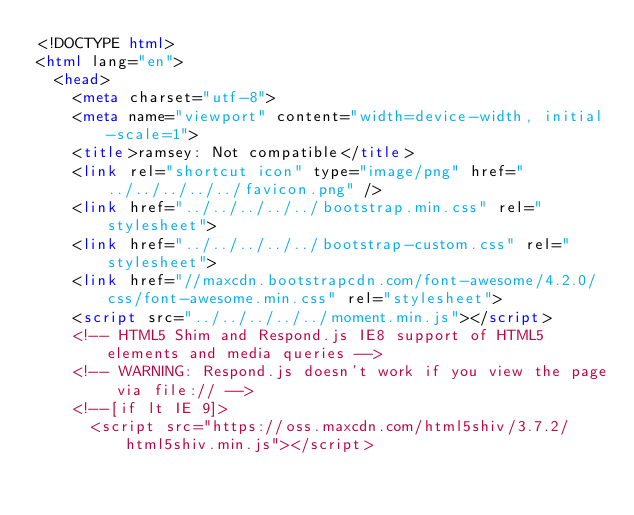<code> <loc_0><loc_0><loc_500><loc_500><_HTML_><!DOCTYPE html>
<html lang="en">
  <head>
    <meta charset="utf-8">
    <meta name="viewport" content="width=device-width, initial-scale=1">
    <title>ramsey: Not compatible</title>
    <link rel="shortcut icon" type="image/png" href="../../../../../favicon.png" />
    <link href="../../../../../bootstrap.min.css" rel="stylesheet">
    <link href="../../../../../bootstrap-custom.css" rel="stylesheet">
    <link href="//maxcdn.bootstrapcdn.com/font-awesome/4.2.0/css/font-awesome.min.css" rel="stylesheet">
    <script src="../../../../../moment.min.js"></script>
    <!-- HTML5 Shim and Respond.js IE8 support of HTML5 elements and media queries -->
    <!-- WARNING: Respond.js doesn't work if you view the page via file:// -->
    <!--[if lt IE 9]>
      <script src="https://oss.maxcdn.com/html5shiv/3.7.2/html5shiv.min.js"></script></code> 